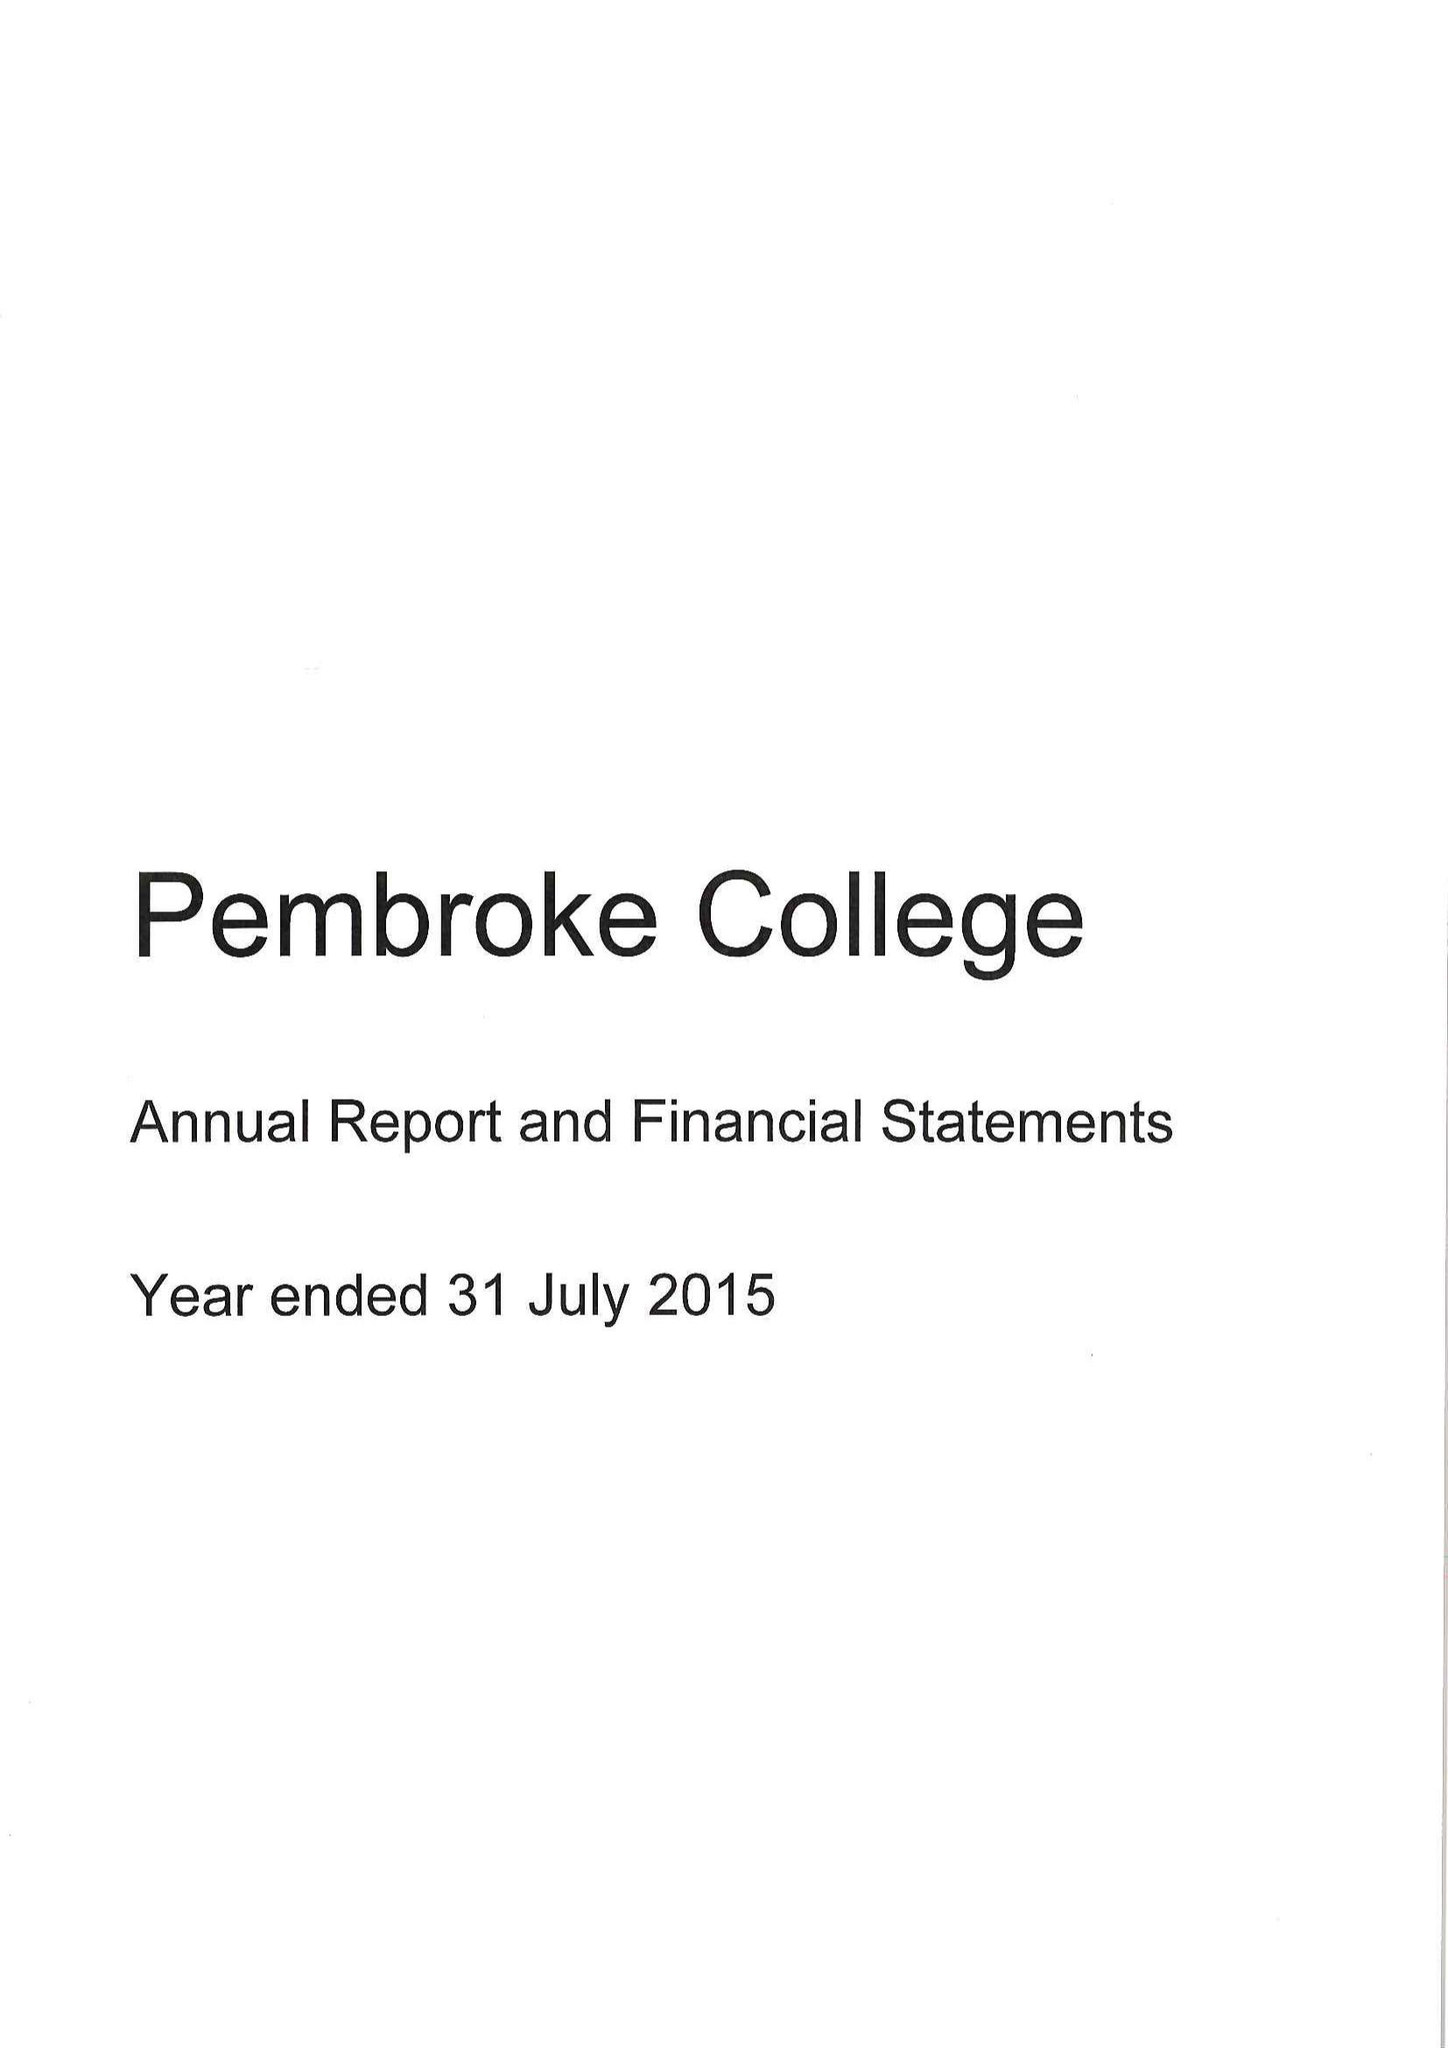What is the value for the charity_name?
Answer the question using a single word or phrase. Master Fellows and Scholars Of Pembroke College 